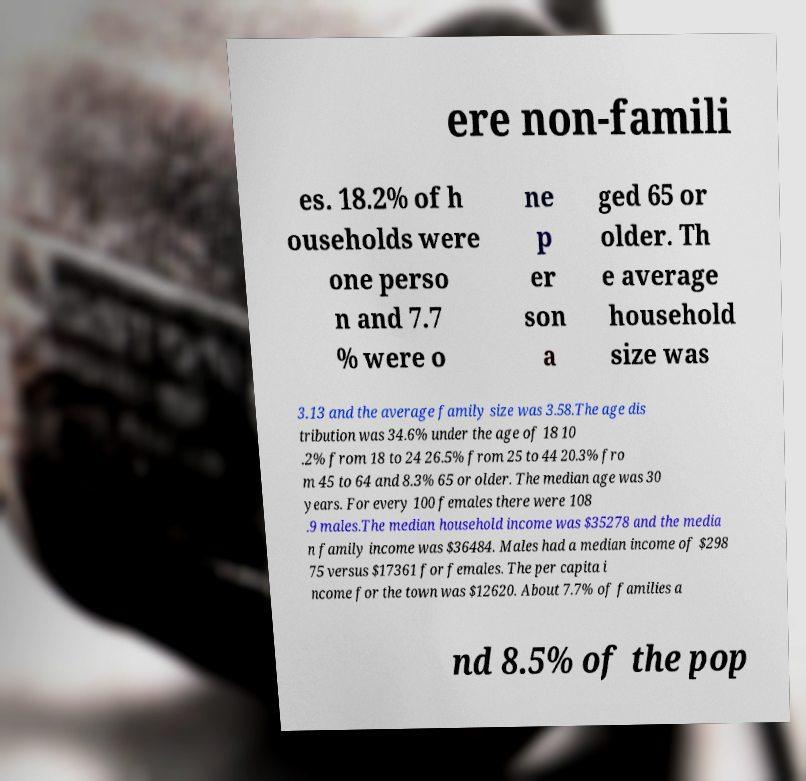Could you assist in decoding the text presented in this image and type it out clearly? ere non-famili es. 18.2% of h ouseholds were one perso n and 7.7 % were o ne p er son a ged 65 or older. Th e average household size was 3.13 and the average family size was 3.58.The age dis tribution was 34.6% under the age of 18 10 .2% from 18 to 24 26.5% from 25 to 44 20.3% fro m 45 to 64 and 8.3% 65 or older. The median age was 30 years. For every 100 females there were 108 .9 males.The median household income was $35278 and the media n family income was $36484. Males had a median income of $298 75 versus $17361 for females. The per capita i ncome for the town was $12620. About 7.7% of families a nd 8.5% of the pop 